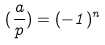<formula> <loc_0><loc_0><loc_500><loc_500>( \frac { a } { p } ) = ( - 1 ) ^ { n }</formula> 